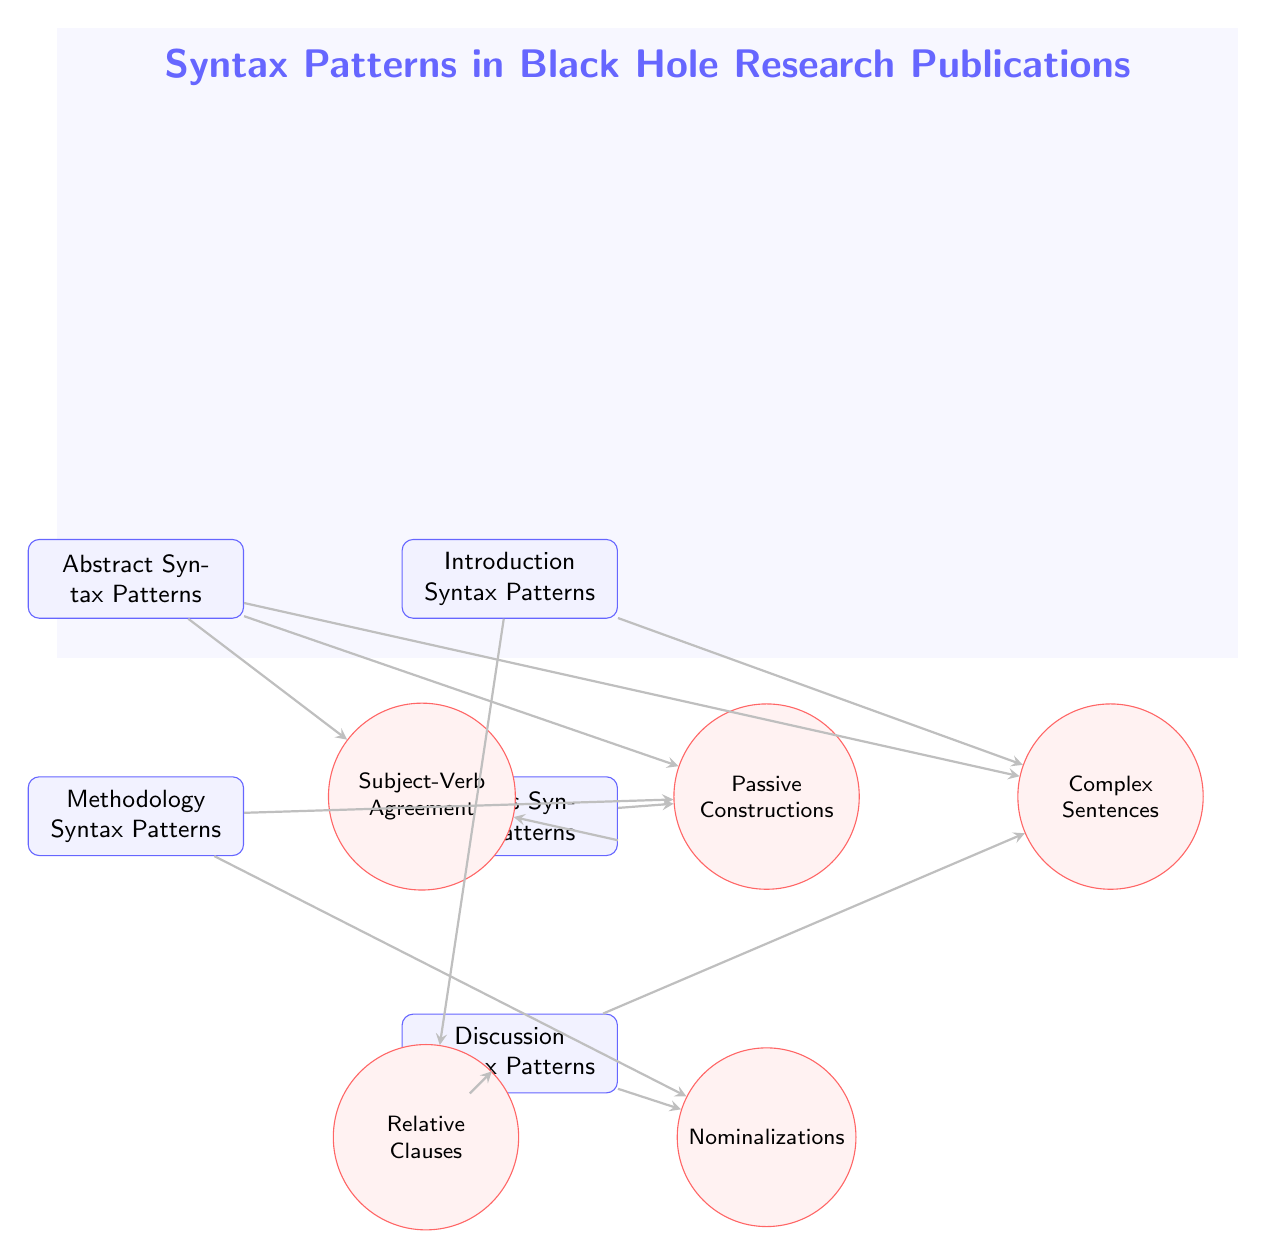What are the categories shown in the diagram? The diagram depicts five main categories: Abstract Syntax Patterns, Introduction Syntax Patterns, Methodology Syntax Patterns, Results Syntax Patterns, and Discussion Syntax Patterns.
Answer: Abstract Syntax Patterns, Introduction Syntax Patterns, Methodology Syntax Patterns, Results Syntax Patterns, Discussion Syntax Patterns How many syntax features are connected to the Abstract Syntax Patterns? The Abstract Syntax Patterns node is connected to three syntax features: Subject-Verb Agreement, Passive Constructions, and Complex Sentences. Therefore, the number of connections is three.
Answer: 3 Which syntax feature is associated with the Discussion category? The Discussion category has connections to Complex Sentences, Relative Clauses, and Nominalizations. Since all are valid connections, highlighting any one will suffice; for simplicity, I will mention one of them, which stands out.
Answer: Complex Sentences What is the relationship between Methodology and Nominalizations? The Methodology category is directly connected to the Nominalizations syntax feature with a directed arrow indicating the relationship. Therefore, the relationship is indeed a direct connection.
Answer: Direct connection How many total nodes are in the diagram? The total count of nodes includes five categories and five syntax features, summing up to ten nodes in total.
Answer: 10 Which syntax feature has a connection with both Results and Abstract categories? The syntax feature Subject-Verb Agreement has a connection with both the Results and Abstract categories, indicating its significance across those areas.
Answer: Subject-Verb Agreement Are there any connections leading from the Introduction category to passive constructions? Upon checking the connections, the Introduction category does not have any direct connections leading to passive constructions. Thus, the answer is no.
Answer: No Which category connects to Relative Clauses? The category that connects to Relative Clauses is both the Introduction and Discussion categories as it has connections leading to both.
Answer: Introduction, Discussion Which category has the most connections to syntax features? The Discussion category connects to three syntax features: Complex Sentences, Relative Clauses, and Nominalizations, making it the category with the most connections.
Answer: Discussion 